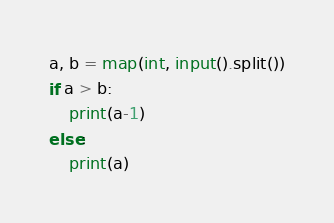<code> <loc_0><loc_0><loc_500><loc_500><_Python_>a, b = map(int, input().split())
if a > b:
    print(a-1)
else:
    print(a)</code> 